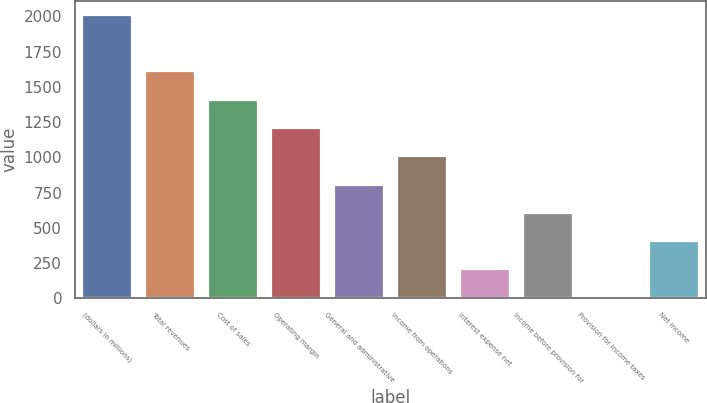Convert chart to OTSL. <chart><loc_0><loc_0><loc_500><loc_500><bar_chart><fcel>(dollars in millions)<fcel>Total revenues<fcel>Cost of sales<fcel>Operating margin<fcel>General and administrative<fcel>Income from operations<fcel>Interest expense net<fcel>Income before provision for<fcel>Provision for income taxes<fcel>Net income<nl><fcel>2011<fcel>1609.56<fcel>1408.84<fcel>1208.12<fcel>806.68<fcel>1007.4<fcel>204.52<fcel>605.96<fcel>3.8<fcel>405.24<nl></chart> 